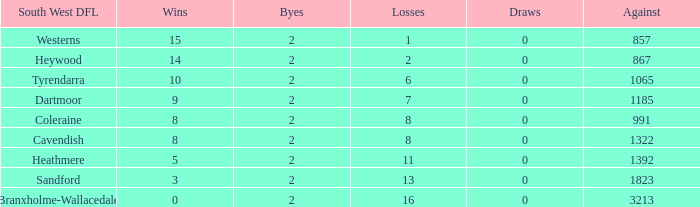How many Draws have a South West DFL of tyrendarra, and less than 10 wins? None. 